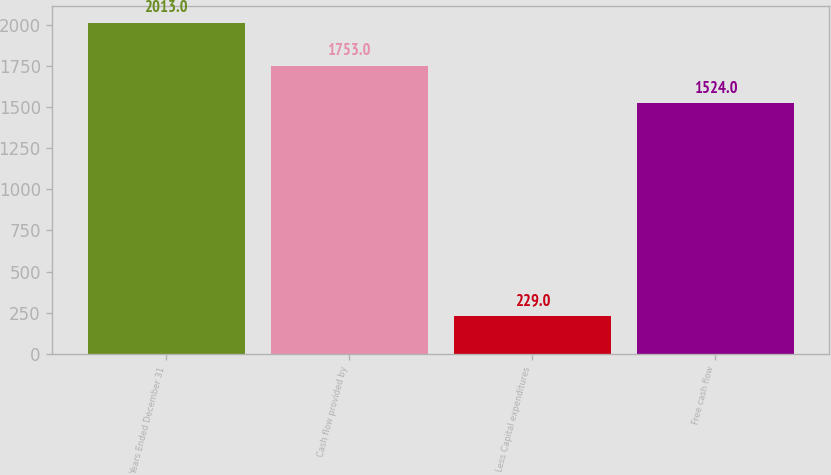Convert chart. <chart><loc_0><loc_0><loc_500><loc_500><bar_chart><fcel>Years Ended December 31<fcel>Cash flow provided by<fcel>Less Capital expenditures<fcel>Free cash flow<nl><fcel>2013<fcel>1753<fcel>229<fcel>1524<nl></chart> 